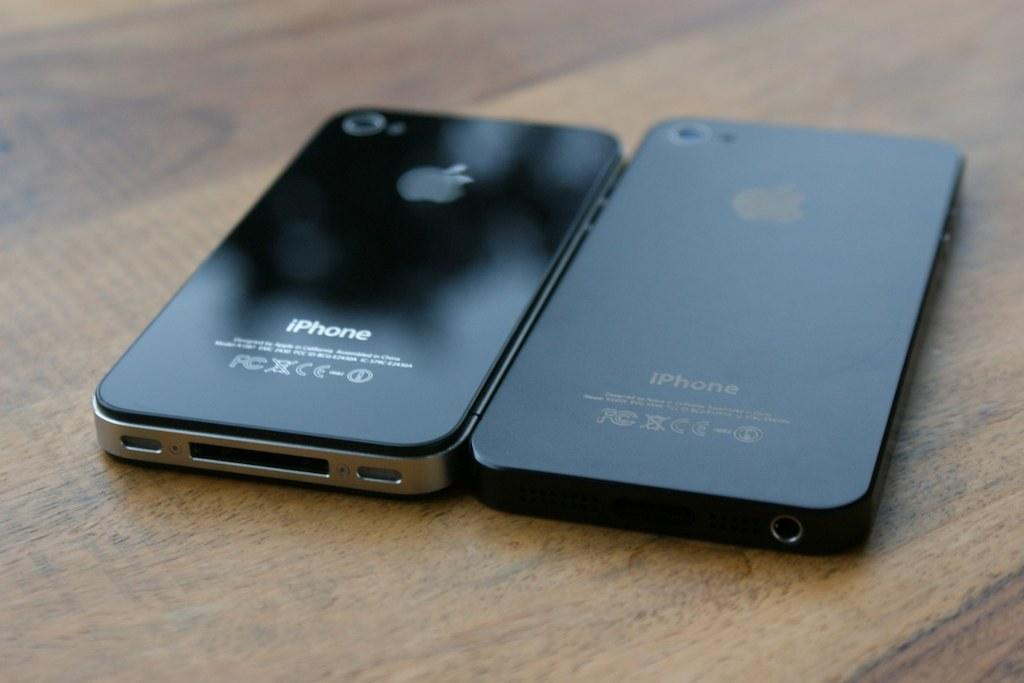<image>
Present a compact description of the photo's key features. Two Iphones sit next to each other with the apple logo in view. 